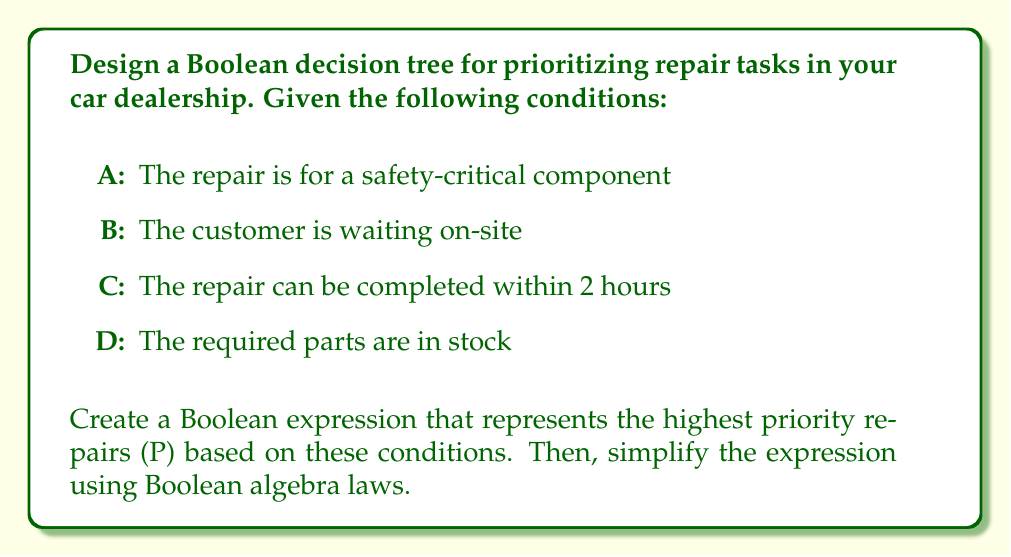Can you solve this math problem? Let's approach this step-by-step:

1) First, we need to define what constitutes the highest priority repairs. These would typically be repairs that are safety-critical, can be completed quickly, and where the customer is waiting and parts are available. This can be represented as:

   $P = A \cdot B \cdot C \cdot D$

2) However, we should also consider that safety-critical repairs should be high priority even if the customer isn't waiting on-site. So we can modify our expression:

   $P = A \cdot (B + \overline{B}) \cdot C \cdot D$

3) Now, let's simplify this expression using Boolean algebra laws:

   $P = A \cdot (B + \overline{B}) \cdot C \cdot D$

4) We can apply the complement law: $B + \overline{B} = 1$

   $P = A \cdot 1 \cdot C \cdot D$

5) The identity law states that $X \cdot 1 = X$, so:

   $P = A \cdot C \cdot D$

6) This simplified expression means that the highest priority repairs are those that are safety-critical (A), can be completed within 2 hours (C), and have the required parts in stock (D).

7) We can represent this as a Boolean decision tree:

[asy]
unitsize(30);
pair A=(0,3), C=(1,2), D=(2,1), P=(3,0);
pair nA=(0,0), nC=(1,1), nD=(2,0);
draw(A--C--D--P);
draw(A--nA);
draw(C--nC);
draw(D--nD);
label("A", A, W);
label("C", C, W);
label("D", D, W);
label("P", P, E);
label("0", nA, E);
label("0", nC, E);
label("0", nD, E);
[/asy]

This tree shows that to reach P (highest priority), we must follow the path where A, C, and D are all true (1).
Answer: $P = A \cdot C \cdot D$ 